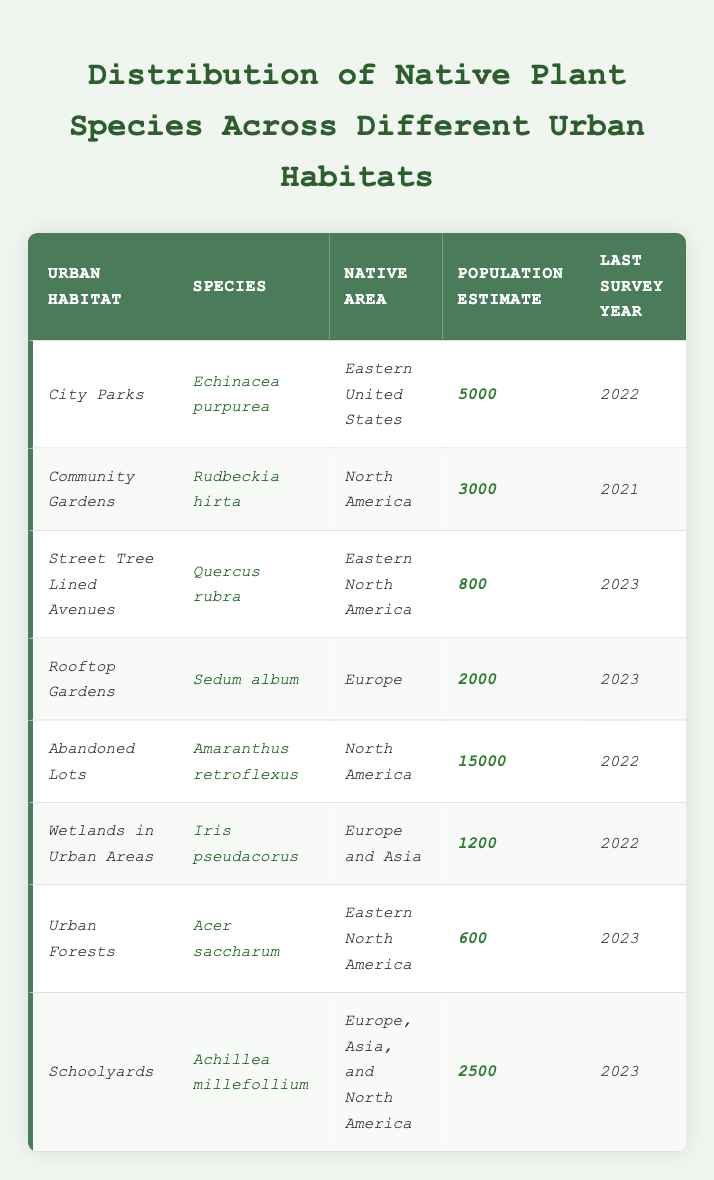What is the population estimate of *Echinacea purpurea*? The population estimate for *Echinacea purpurea* listed under *City Parks* is 5000, as stated directly in the table.
Answer: 5000 Which urban habitat has the highest native plant species population estimate? The habitat with the highest population estimate is *Abandoned Lots*, where the estimate for *Amaranthus retroflexus* is 15000, which is greater than any other habitat listed.
Answer: Abandoned Lots How many native plant species are documented in *Rooftop Gardens*? The table indicates that there is only one native plant species documented in *Rooftop Gardens*, which is *Sedum album*.
Answer: 1 What is the last survey year for *Rudbeckia hirta*? The last survey year for *Rudbeckia hirta*, located in *Community Gardens*, is noted as 2021 in the table.
Answer: 2021 Is there a native plant species recorded in *Urban Forests*? Yes, the table shows that *Acer saccharum*, a native plant species, is recorded in *Urban Forests*.
Answer: Yes What is the average population estimate for the species listed in *Schoolyards* and *Wetlands in Urban Areas*? The population estimate for *Schoolyards* is 2500 and for *Wetlands in Urban Areas* is 1200. To find the average, calculate (2500 + 1200) / 2 = 1850.
Answer: 1850 What is the total population estimate of all species in urban habitats surveyed in 2023? The species surveyed in 2023 are *Quercus rubra* (800), *Sedum album* (2000), *Acer saccharum* (600), and *Achillea millefollium* (2500). Summing these gives 800 + 2000 + 600 + 2500 = 4900.
Answer: 4900 Which species has the lowest population estimate, and where is it found? Looking at the table, *Acer saccharum* found in *Urban Forests* has the lowest population estimate at 600.
Answer: Acer saccharum in Urban Forests Are there more native species from Europe than from North America in urban habitats listed? In the table, species from Europe (*Sedum album* and *Iris pseudacorus*) are a total of 2, while from North America (*Rudbeckia hirta*, *Amaranthus retroflexus*, *Quercus rubra*, *Acer saccharum*) there are 4 species. Thus, there are not more from Europe.
Answer: No What percentage of the total population estimate does *Abandoned Lots* contribute? The total population sum for all habitats is 5000 + 3000 + 800 + 2000 + 15000 + 1200 + 600 + 2500 = 25000. The estimate for *Abandoned Lots* is 15000. Therefore, the percentage is (15000 / 25000) * 100 = 60%.
Answer: 60% 